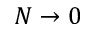Convert formula to latex. <formula><loc_0><loc_0><loc_500><loc_500>N \rightarrow 0</formula> 